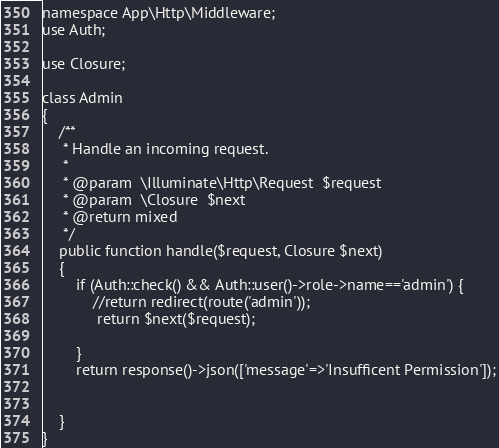<code> <loc_0><loc_0><loc_500><loc_500><_PHP_>namespace App\Http\Middleware;
use Auth;

use Closure;

class Admin
{
    /**
     * Handle an incoming request.
     *
     * @param  \Illuminate\Http\Request  $request
     * @param  \Closure  $next
     * @return mixed
     */
    public function handle($request, Closure $next)
    {
        if (Auth::check() && Auth::user()->role->name=='admin') {
            //return redirect(route('admin'));
             return $next($request);
            
        }
        return response()->json(['message'=>'Insufficent Permission']);

       
    }
}
</code> 